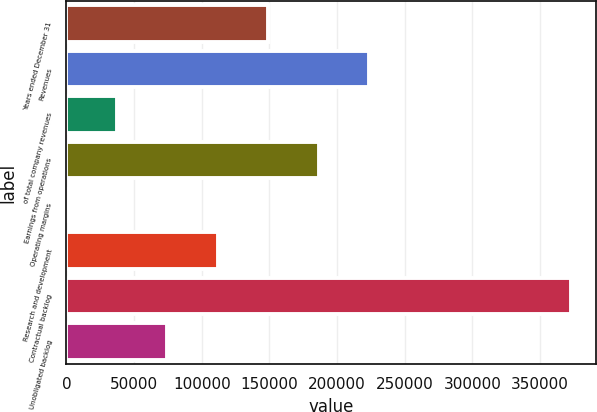Convert chart to OTSL. <chart><loc_0><loc_0><loc_500><loc_500><bar_chart><fcel>Years ended December 31<fcel>Revenues<fcel>of total company revenues<fcel>Earnings from operations<fcel>Operating margins<fcel>Research and development<fcel>Contractual backlog<fcel>Unobligated backlog<nl><fcel>149199<fcel>223792<fcel>37307.8<fcel>186495<fcel>10.9<fcel>111902<fcel>372980<fcel>74604.7<nl></chart> 